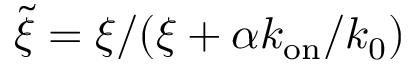<formula> <loc_0><loc_0><loc_500><loc_500>\tilde { \xi } = \xi / ( \xi + \alpha k _ { o n } / k _ { 0 } )</formula> 